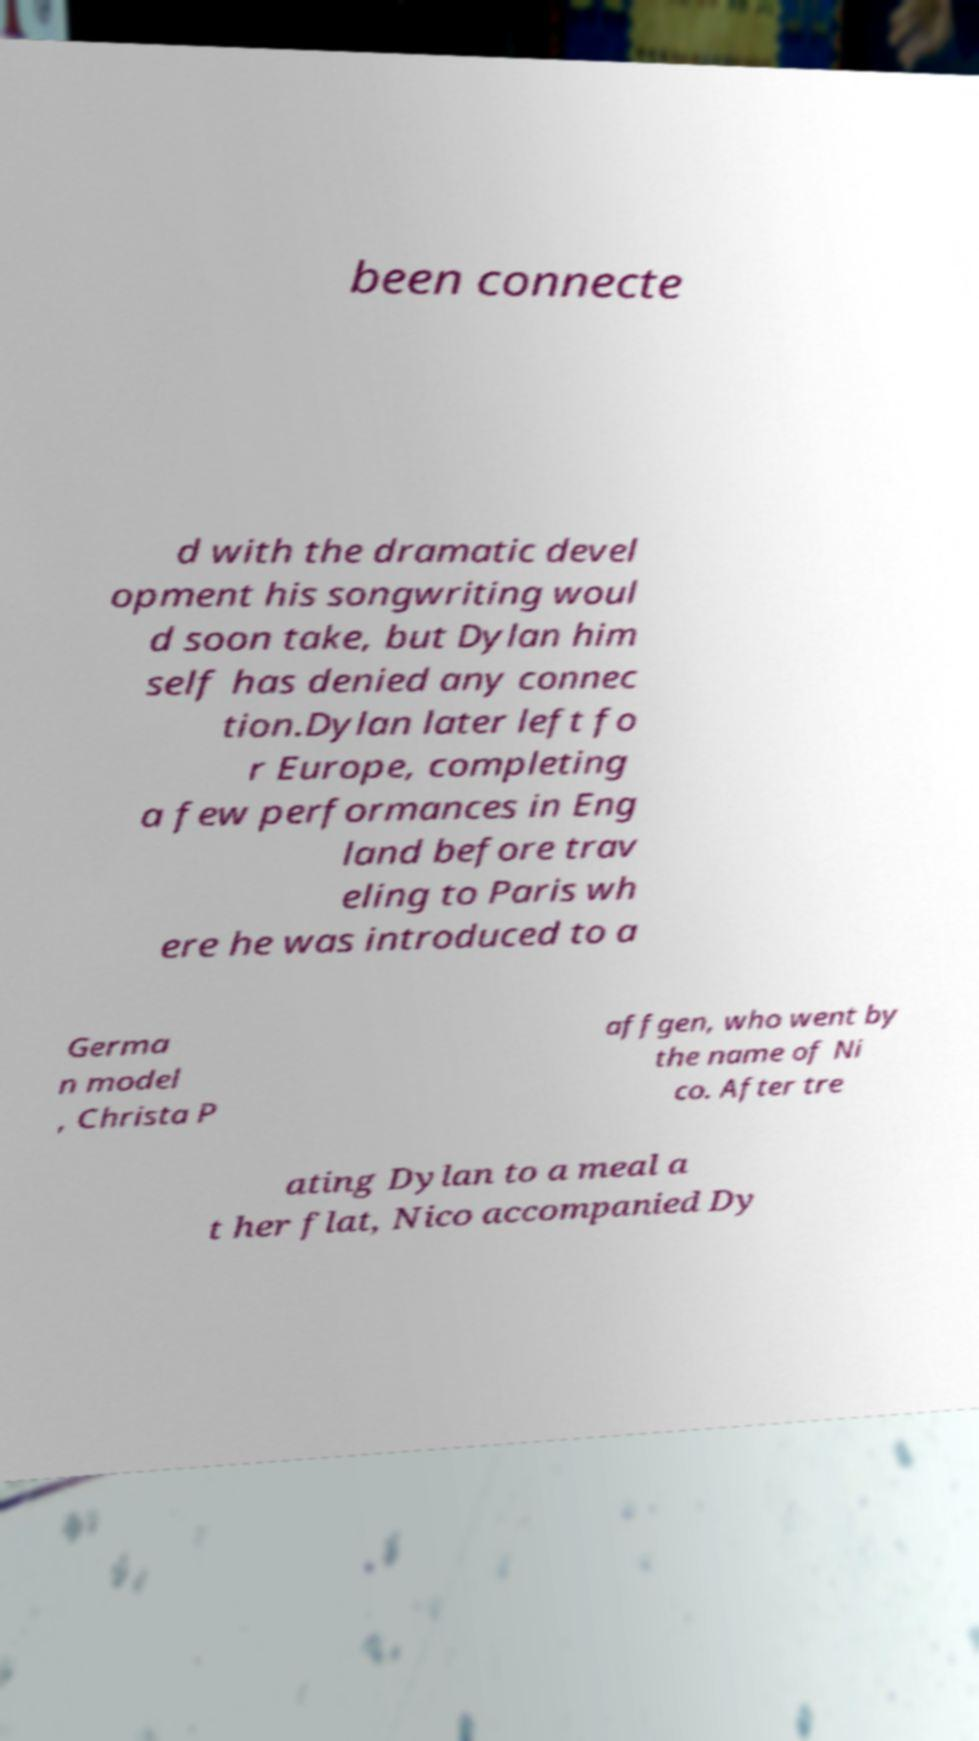Can you accurately transcribe the text from the provided image for me? been connecte d with the dramatic devel opment his songwriting woul d soon take, but Dylan him self has denied any connec tion.Dylan later left fo r Europe, completing a few performances in Eng land before trav eling to Paris wh ere he was introduced to a Germa n model , Christa P affgen, who went by the name of Ni co. After tre ating Dylan to a meal a t her flat, Nico accompanied Dy 